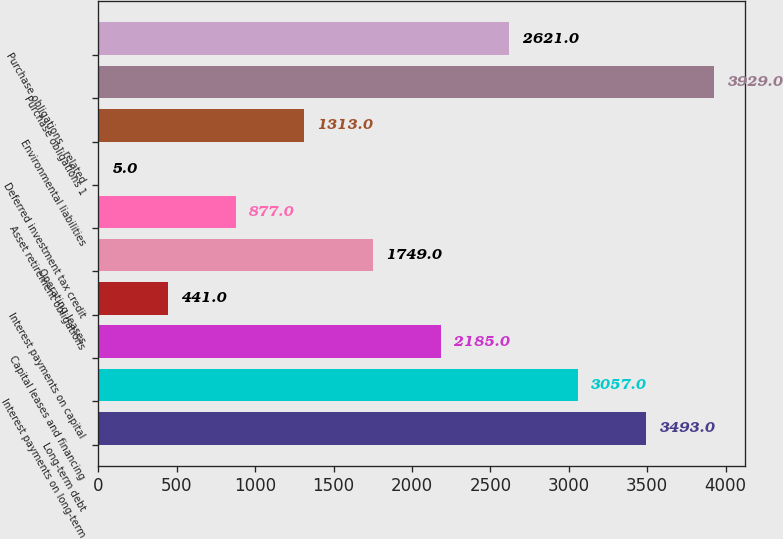Convert chart. <chart><loc_0><loc_0><loc_500><loc_500><bar_chart><fcel>Long-term debt<fcel>Interest payments on long-term<fcel>Capital leases and financing<fcel>Interest payments on capital<fcel>Operating leases<fcel>Asset retirement obligations<fcel>Deferred investment tax credit<fcel>Environmental liabilities<fcel>Purchase obligations 1<fcel>Purchase obligations - related<nl><fcel>3493<fcel>3057<fcel>2185<fcel>441<fcel>1749<fcel>877<fcel>5<fcel>1313<fcel>3929<fcel>2621<nl></chart> 